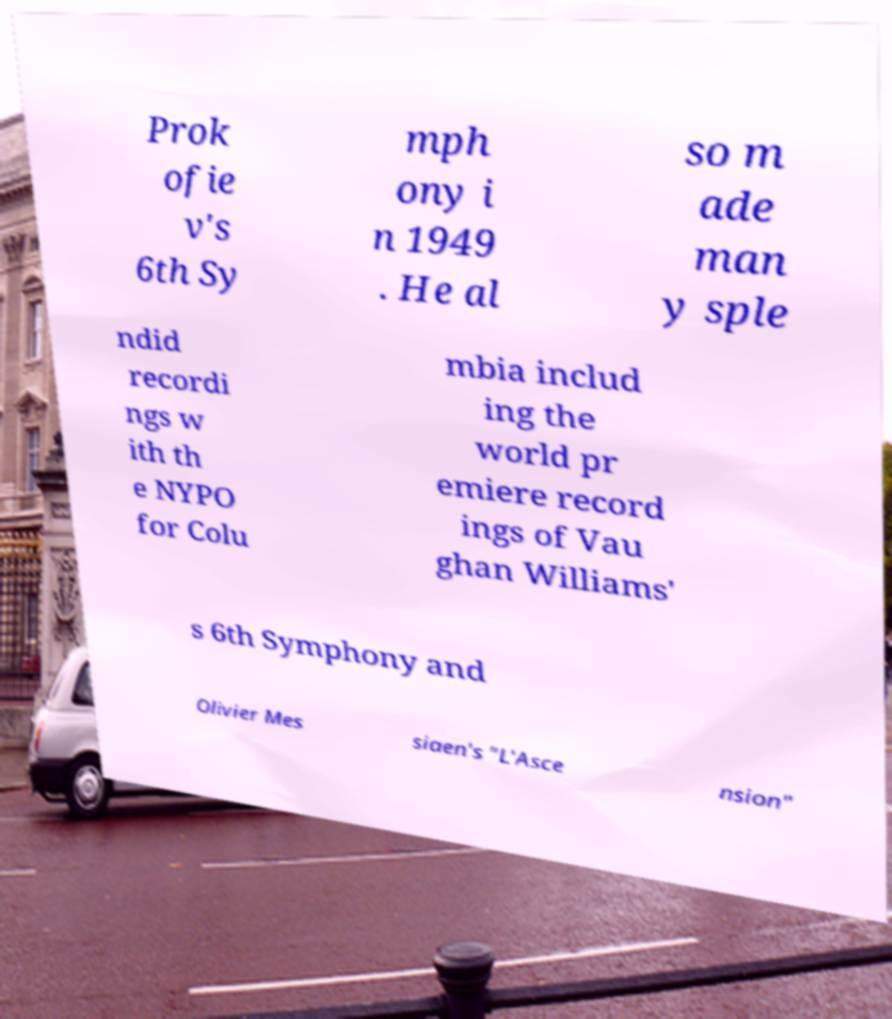Can you accurately transcribe the text from the provided image for me? Prok ofie v's 6th Sy mph ony i n 1949 . He al so m ade man y sple ndid recordi ngs w ith th e NYPO for Colu mbia includ ing the world pr emiere record ings of Vau ghan Williams' s 6th Symphony and Olivier Mes siaen's "L'Asce nsion" 